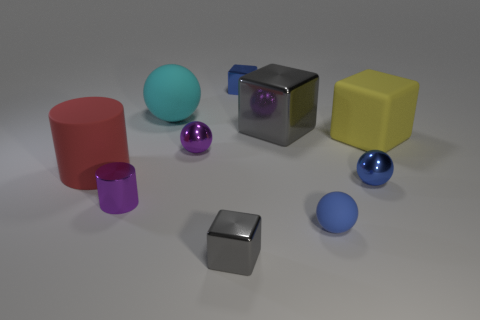How many other large yellow things have the same shape as the yellow rubber thing?
Provide a short and direct response. 0. What is the material of the small block that is the same color as the big shiny thing?
Your answer should be compact. Metal. What number of big green matte cubes are there?
Offer a terse response. 0. There is a cyan thing; is it the same shape as the big rubber thing that is right of the blue block?
Your answer should be compact. No. How many things are blocks or blue objects in front of the red matte thing?
Your answer should be very brief. 6. There is another tiny thing that is the same shape as the red thing; what material is it?
Your answer should be compact. Metal. Is the shape of the large thing in front of the purple metal sphere the same as  the blue rubber object?
Ensure brevity in your answer.  No. Is there any other thing that has the same size as the red rubber cylinder?
Keep it short and to the point. Yes. Is the number of tiny purple metallic objects behind the red cylinder less than the number of gray metallic objects on the left side of the tiny purple sphere?
Make the answer very short. No. What number of other objects are the same shape as the large yellow object?
Make the answer very short. 3. 